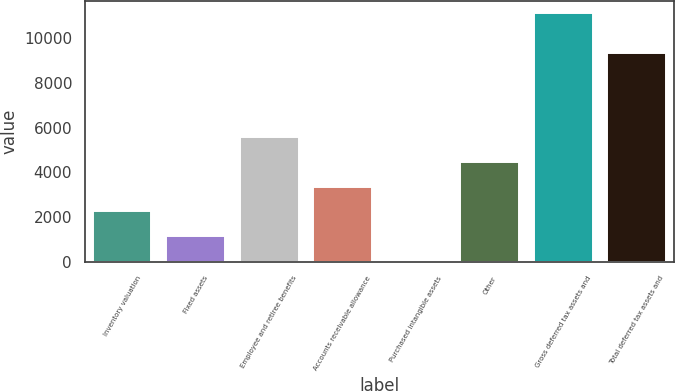Convert chart. <chart><loc_0><loc_0><loc_500><loc_500><bar_chart><fcel>Inventory valuation<fcel>Fixed assets<fcel>Employee and retiree benefits<fcel>Accounts receivable allowance<fcel>Purchased intangible assets<fcel>Other<fcel>Gross deferred tax assets and<fcel>Total deferred tax assets and<nl><fcel>2248.2<fcel>1139.1<fcel>5575.5<fcel>3357.3<fcel>30<fcel>4466.4<fcel>11121<fcel>9320<nl></chart> 